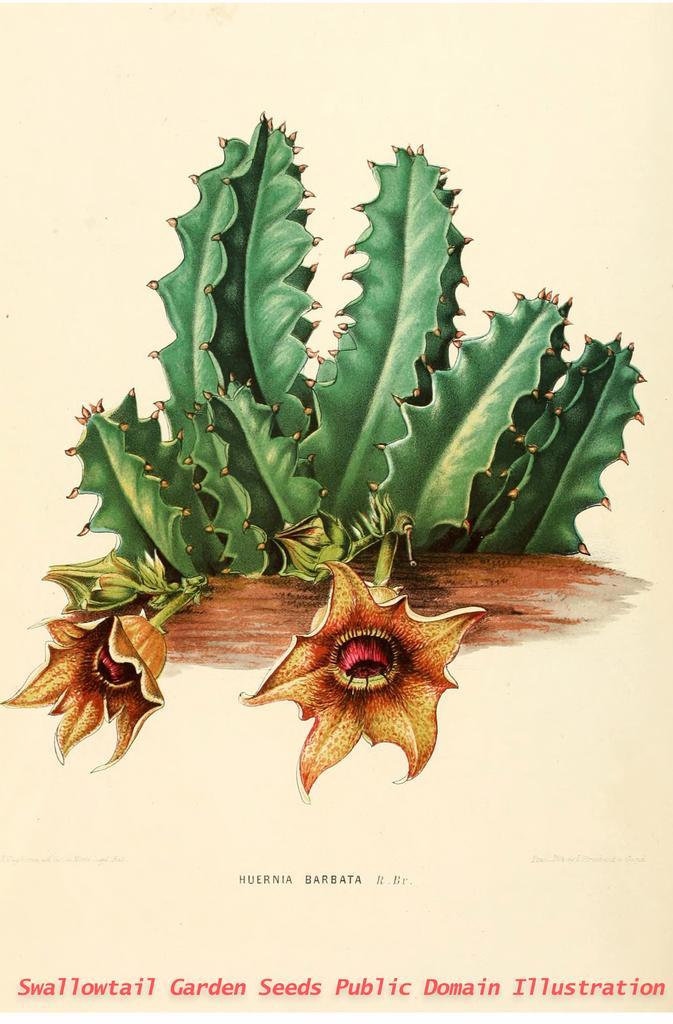How would you summarize this image in a sentence or two? In this image I can see few flowers in brown and red color, plants in green color and I can see the cream color background. I can see something written on the image. 